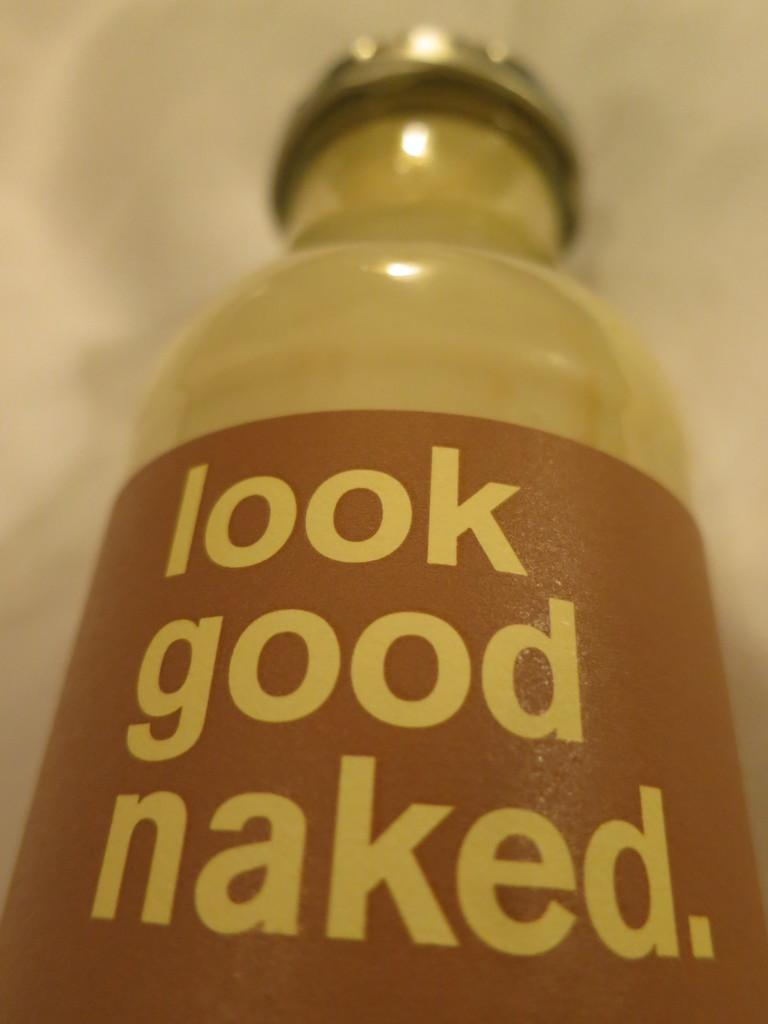What object is present on the floor in the image? There is a bottle on the floor in the image. What is on the bottle? The bottle has a sticker and a cap. What type of authority does the veil represent in the image? There is no veil present in the image; it only features a bottle with a sticker and cap. 